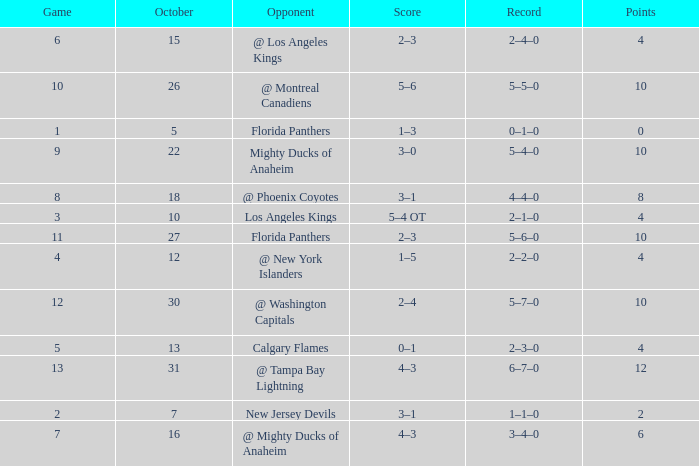What team has a score of 2 3–1. 